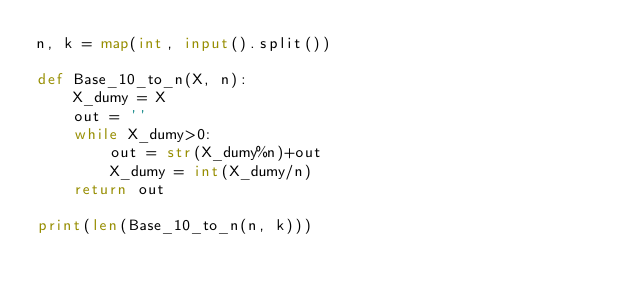Convert code to text. <code><loc_0><loc_0><loc_500><loc_500><_Python_>n, k = map(int, input().split())

def Base_10_to_n(X, n):
    X_dumy = X
    out = ''
    while X_dumy>0:
        out = str(X_dumy%n)+out
        X_dumy = int(X_dumy/n)
    return out

print(len(Base_10_to_n(n, k)))</code> 